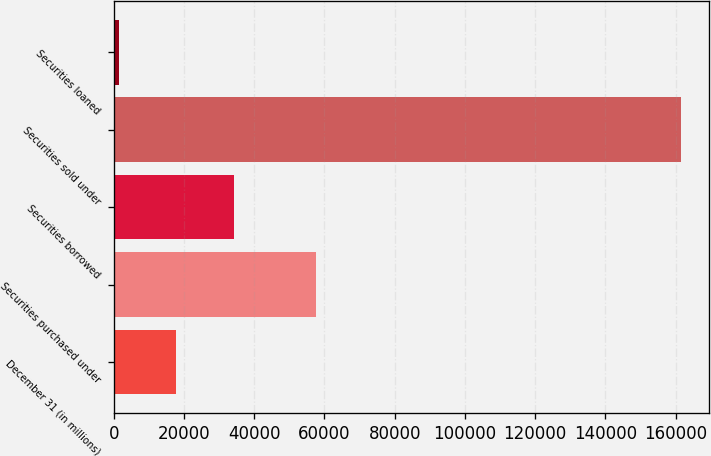<chart> <loc_0><loc_0><loc_500><loc_500><bar_chart><fcel>December 31 (in millions)<fcel>Securities purchased under<fcel>Securities borrowed<fcel>Securities sold under<fcel>Securities loaned<nl><fcel>17634.3<fcel>57645<fcel>34143<fcel>161394<fcel>1661<nl></chart> 